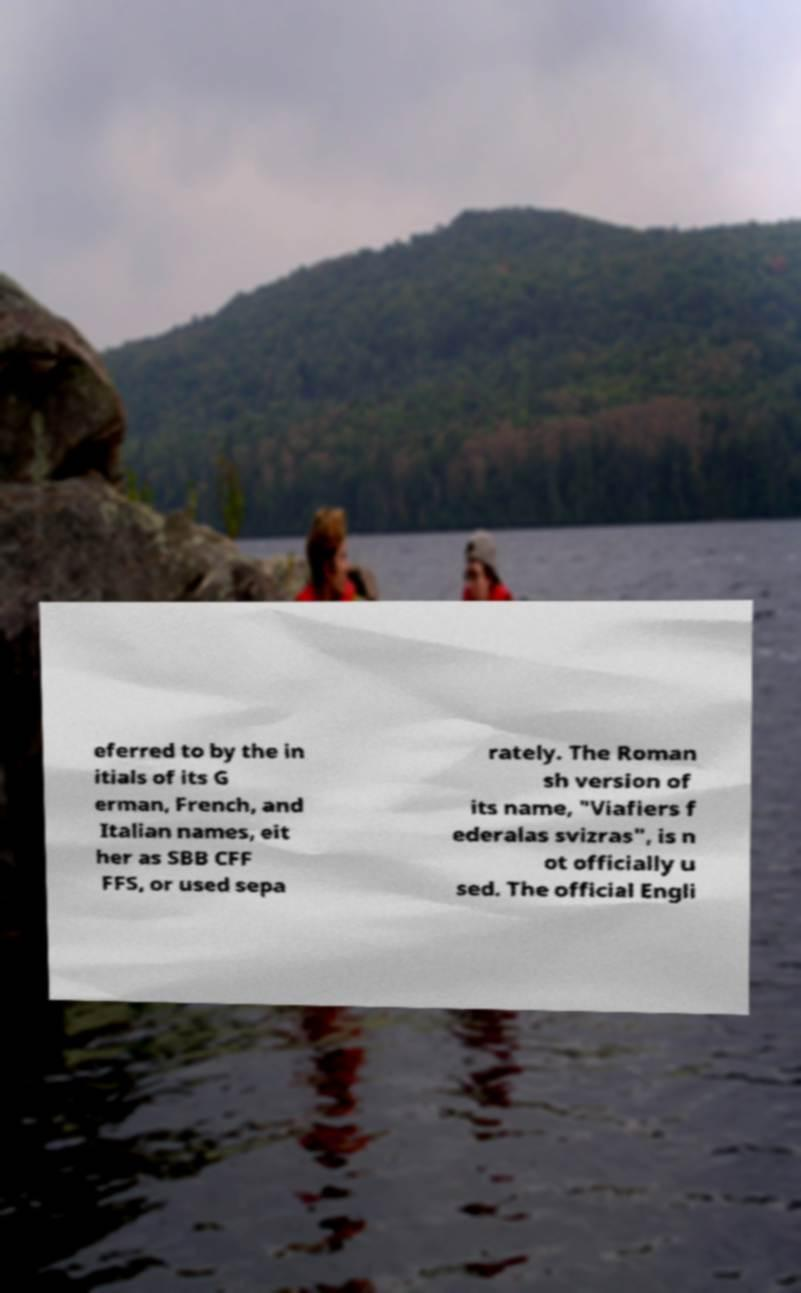Could you extract and type out the text from this image? eferred to by the in itials of its G erman, French, and Italian names, eit her as SBB CFF FFS, or used sepa rately. The Roman sh version of its name, "Viafiers f ederalas svizras", is n ot officially u sed. The official Engli 